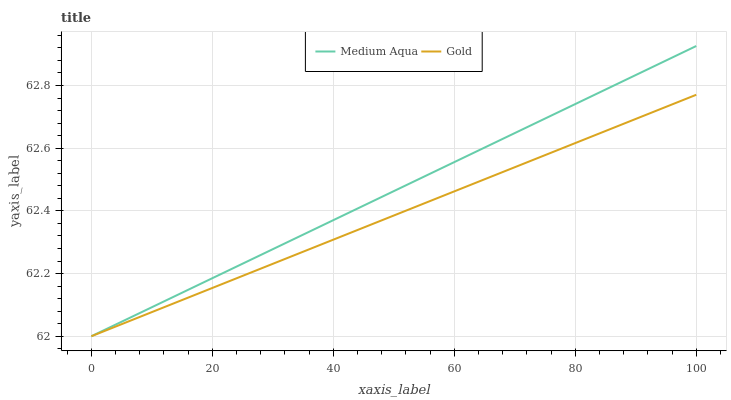Does Gold have the minimum area under the curve?
Answer yes or no. Yes. Does Medium Aqua have the maximum area under the curve?
Answer yes or no. Yes. Does Gold have the maximum area under the curve?
Answer yes or no. No. Is Gold the smoothest?
Answer yes or no. Yes. Is Medium Aqua the roughest?
Answer yes or no. Yes. Is Gold the roughest?
Answer yes or no. No. Does Medium Aqua have the lowest value?
Answer yes or no. Yes. Does Medium Aqua have the highest value?
Answer yes or no. Yes. Does Gold have the highest value?
Answer yes or no. No. Does Medium Aqua intersect Gold?
Answer yes or no. Yes. Is Medium Aqua less than Gold?
Answer yes or no. No. Is Medium Aqua greater than Gold?
Answer yes or no. No. 